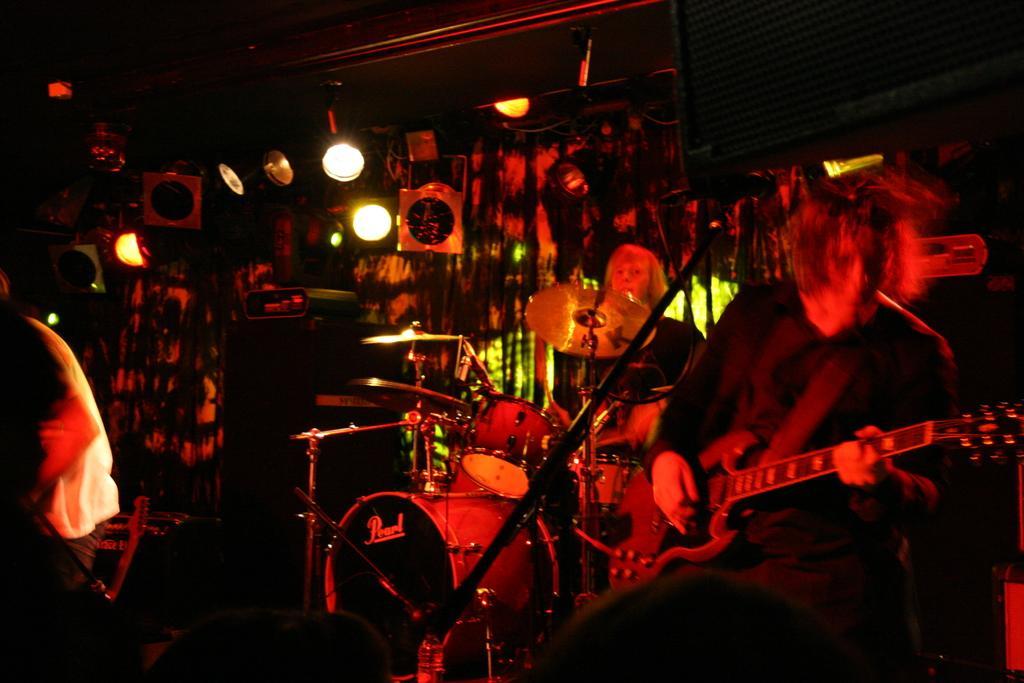In one or two sentences, can you explain what this image depicts? It is a music concert, there is totally a red color light covered the room there are two people can be seen in the picture,first person is playing the guitar and the second person is playing drums, in the background there is a curtain a lot of lights. 